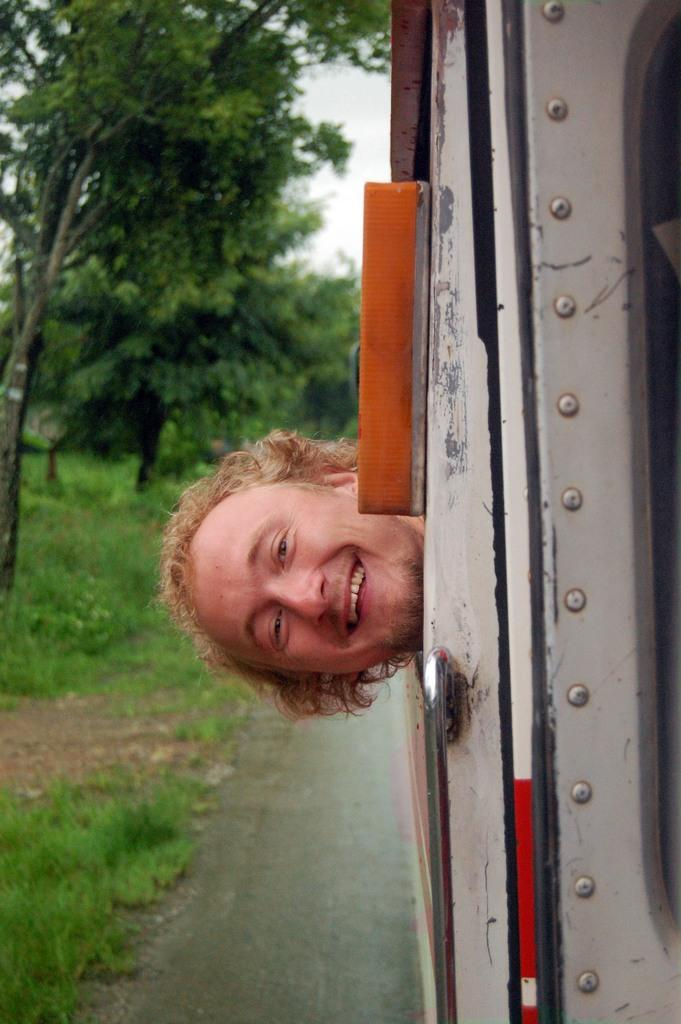Who or what is in the image? There is a person in the image. What is the person doing in the image? The person's head is outside the vehicle, and they are watching and smiling. What can be seen on the left side of the image? There are trees, grass, and a road on the left side of the image. What is visible in the background of the image? The sky is visible in the image. What type of lace can be seen on the person's clothing in the image? There is no lace visible on the person's clothing in the image. What type of business is being conducted in the image? There is no indication of any business being conducted in the image; it primarily features a person with their head outside a vehicle. 